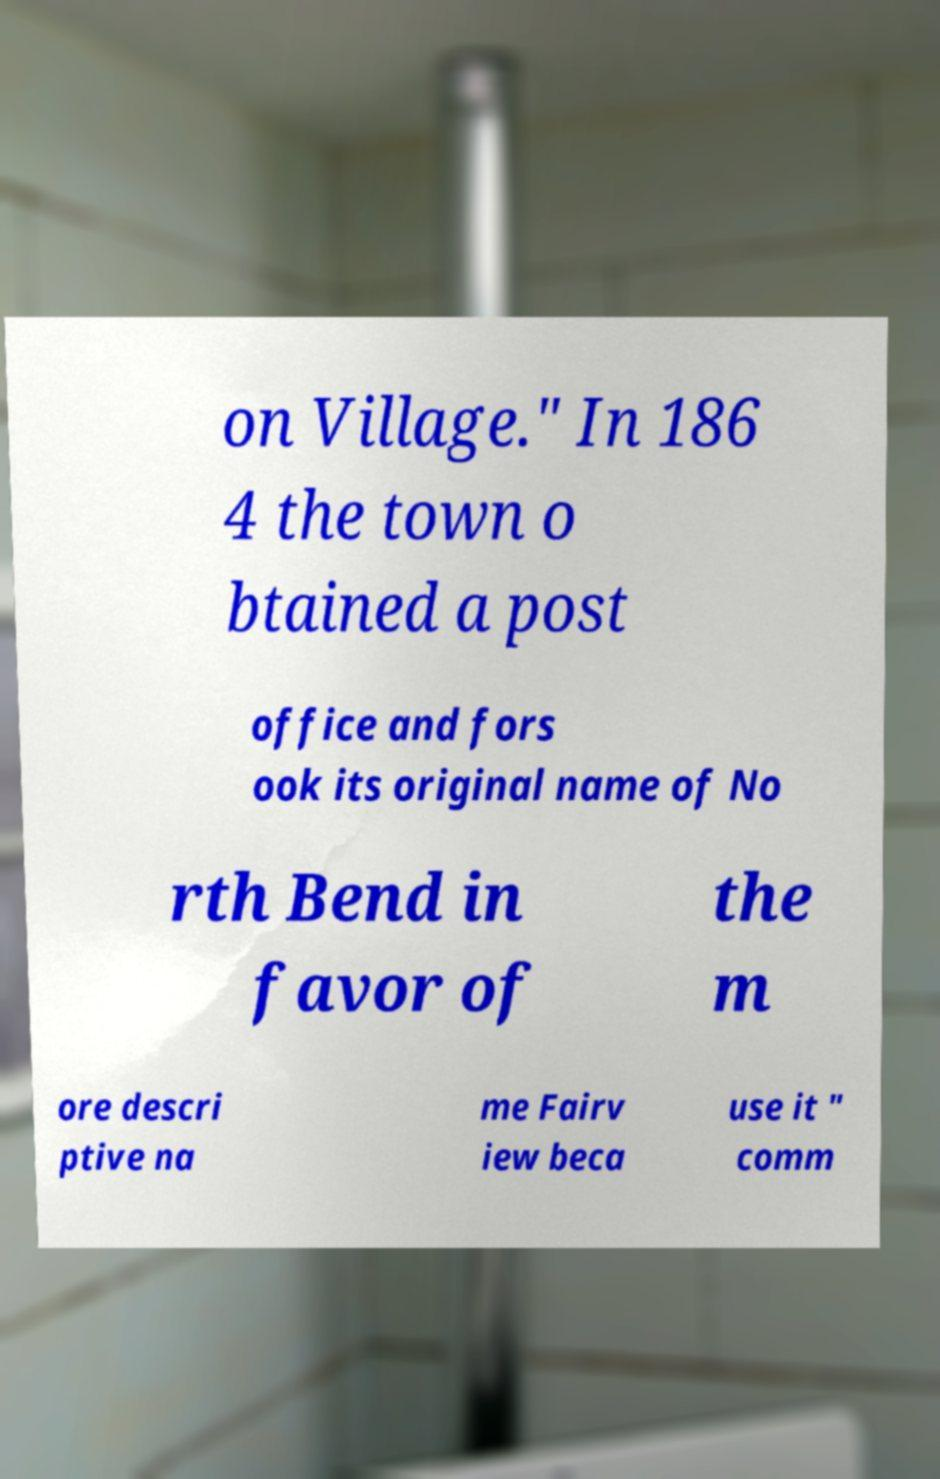Could you extract and type out the text from this image? on Village." In 186 4 the town o btained a post office and fors ook its original name of No rth Bend in favor of the m ore descri ptive na me Fairv iew beca use it " comm 